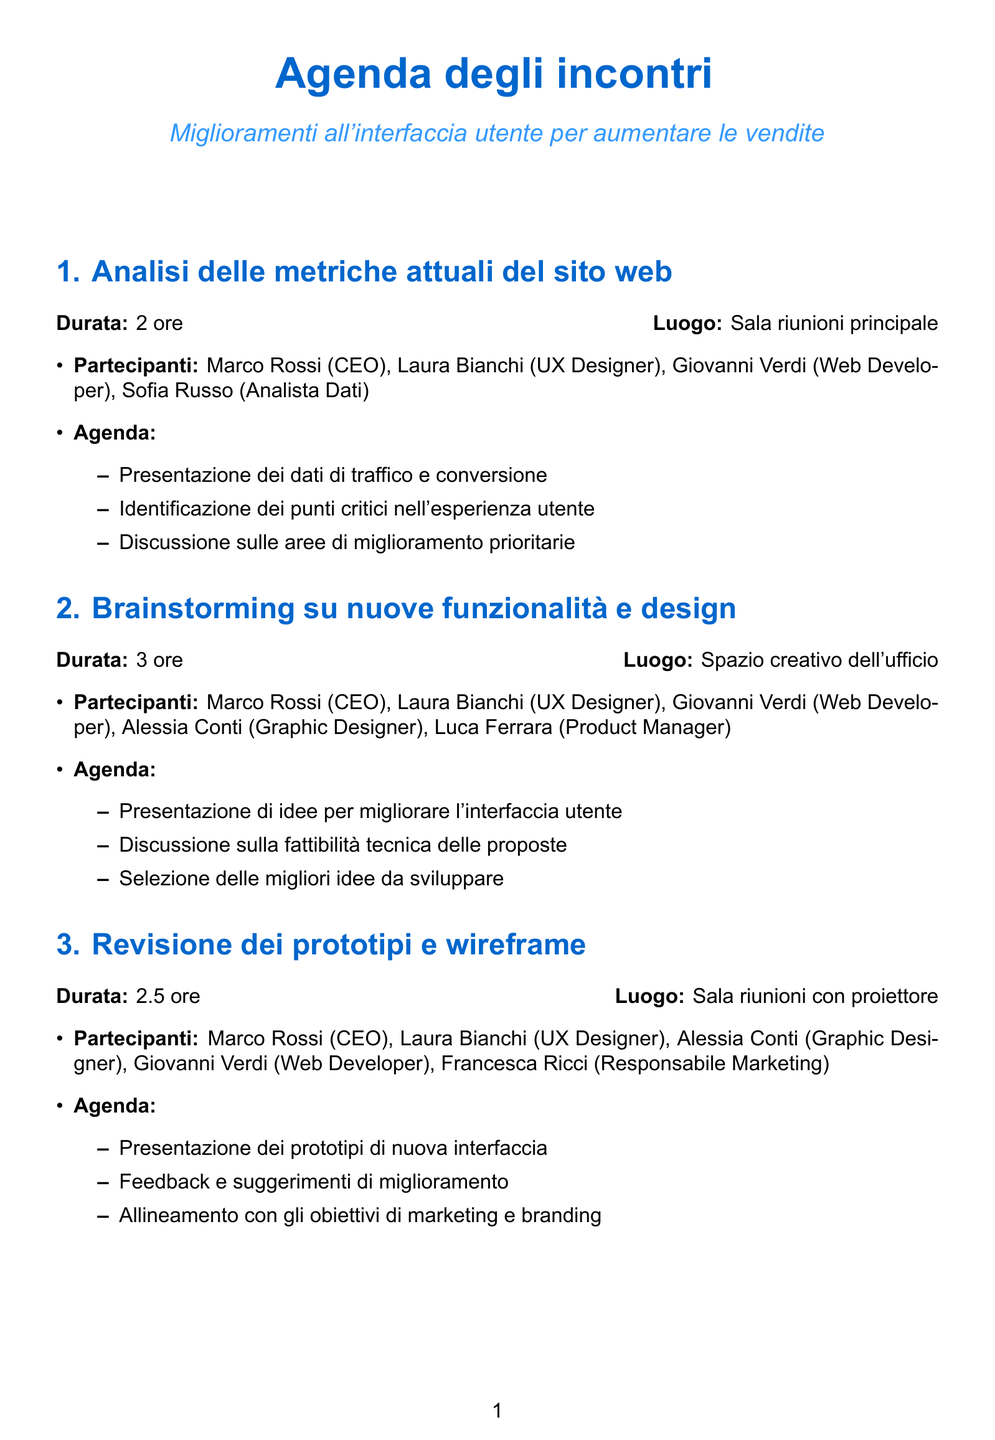Qual è la durata dell'incontro "Analisi delle metriche attuali del sito web"? La durata è specificata nel documento come 2 ore per l'incontro.
Answer: 2 ore Chi partecipa all'incontro "Brainstorming su nuove funzionalità e design"? L'elenco dei partecipanti è fornito nell'agenda di ciascun incontro, per questo incontro include Marco Rossi, Laura Bianchi, Giovanni Verdi, Alessia Conti, e Luca Ferrara.
Answer: Marco Rossi, Laura Bianchi, Giovanni Verdi, Alessia Conti, Luca Ferrara Qual è il luogo dell'incontro "Revisione dei prototipi e wireframe"? Il luogo è indicato nel documento come Sala riunioni con proiettore per questo incontro.
Answer: Sala riunioni con proiettore In quale incontro si discute dell'analisi costi-benefici e ROI previsto? Questa discussione è parte dell'agenda nell'incontro di Presentazione finale e approvazione del progetto.
Answer: Presentazione finale e approvazione del progetto Qual è la durata totale degli incontri? La somma delle durate degli incontri specificati nel documento è 2 ore + 3 ore + 2.5 ore + 4 ore + 3 ore, che risulta in 14.5 ore.
Answer: 14.5 ore 